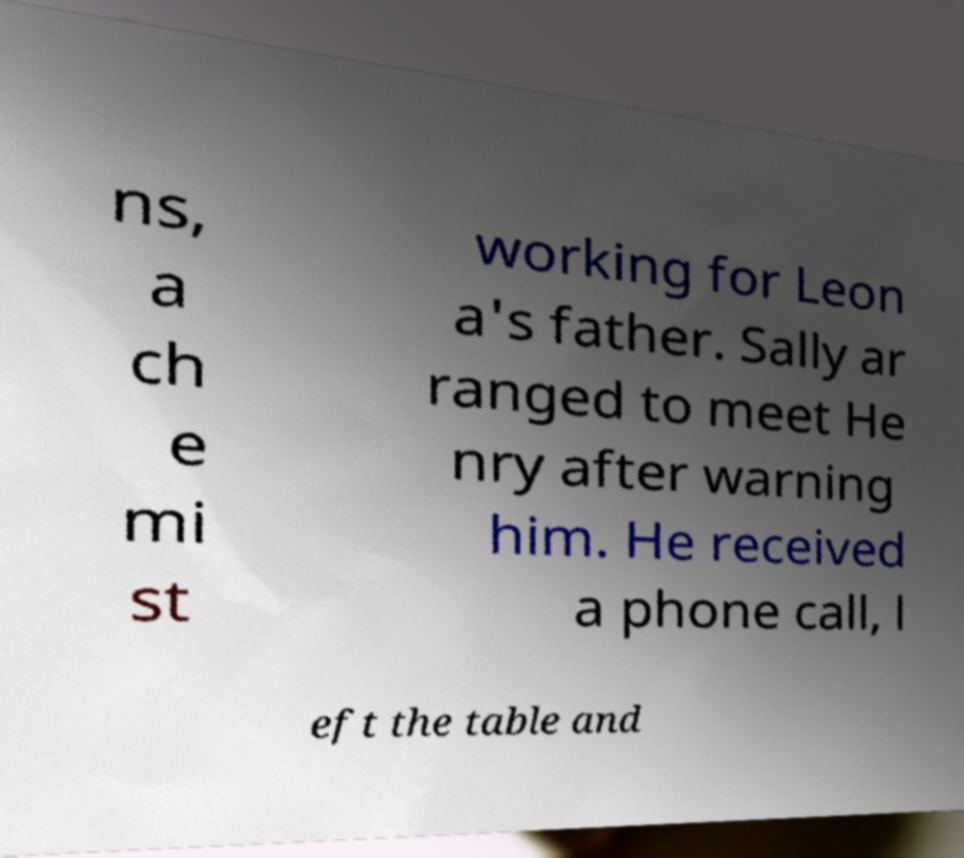Could you assist in decoding the text presented in this image and type it out clearly? ns, a ch e mi st working for Leon a's father. Sally ar ranged to meet He nry after warning him. He received a phone call, l eft the table and 